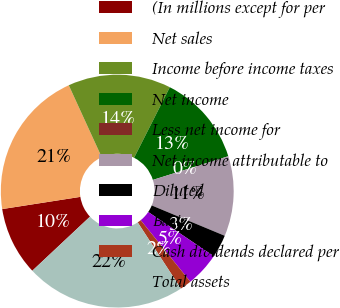Convert chart to OTSL. <chart><loc_0><loc_0><loc_500><loc_500><pie_chart><fcel>(In millions except for per<fcel>Net sales<fcel>Income before income taxes<fcel>Net income<fcel>Less net income for<fcel>Net income attributable to<fcel>Diluted<fcel>Basic<fcel>Cash dividends declared per<fcel>Total assets<nl><fcel>9.52%<fcel>20.63%<fcel>14.29%<fcel>12.7%<fcel>0.0%<fcel>11.11%<fcel>3.17%<fcel>4.76%<fcel>1.59%<fcel>22.22%<nl></chart> 